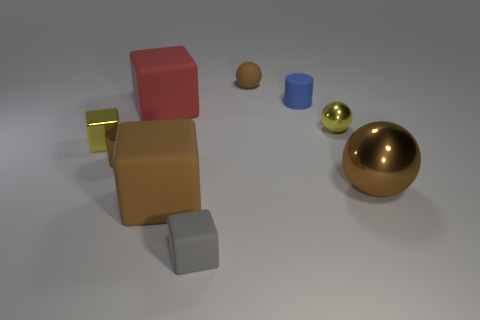What number of other objects are the same material as the large red thing?
Provide a succinct answer. 4. Are there more tiny cyan metallic spheres than tiny cubes?
Provide a short and direct response. No. There is a brown metallic object to the left of the tiny gray matte thing; does it have the same shape as the gray object?
Make the answer very short. No. Are there fewer metal cylinders than yellow objects?
Provide a succinct answer. Yes. There is a yellow cube that is the same size as the gray object; what is its material?
Offer a terse response. Metal. There is a tiny metal cylinder; does it have the same color as the big block that is in front of the small yellow ball?
Offer a terse response. Yes. Are there fewer big brown things to the right of the blue thing than large balls?
Make the answer very short. No. How many cylinders are there?
Give a very brief answer. 2. There is a big thing that is to the right of the sphere on the left side of the matte cylinder; what is its shape?
Your response must be concise. Sphere. There is a big red matte object; what number of large shiny things are to the left of it?
Give a very brief answer. 0. 